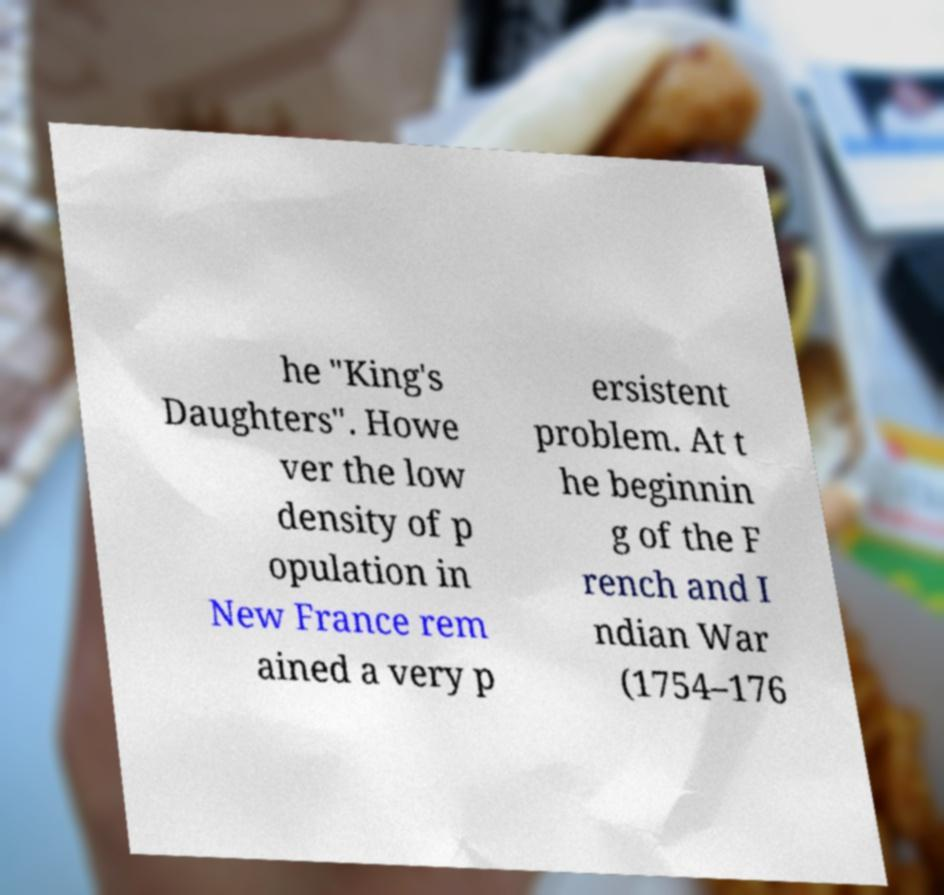Please read and relay the text visible in this image. What does it say? he "King's Daughters". Howe ver the low density of p opulation in New France rem ained a very p ersistent problem. At t he beginnin g of the F rench and I ndian War (1754–176 